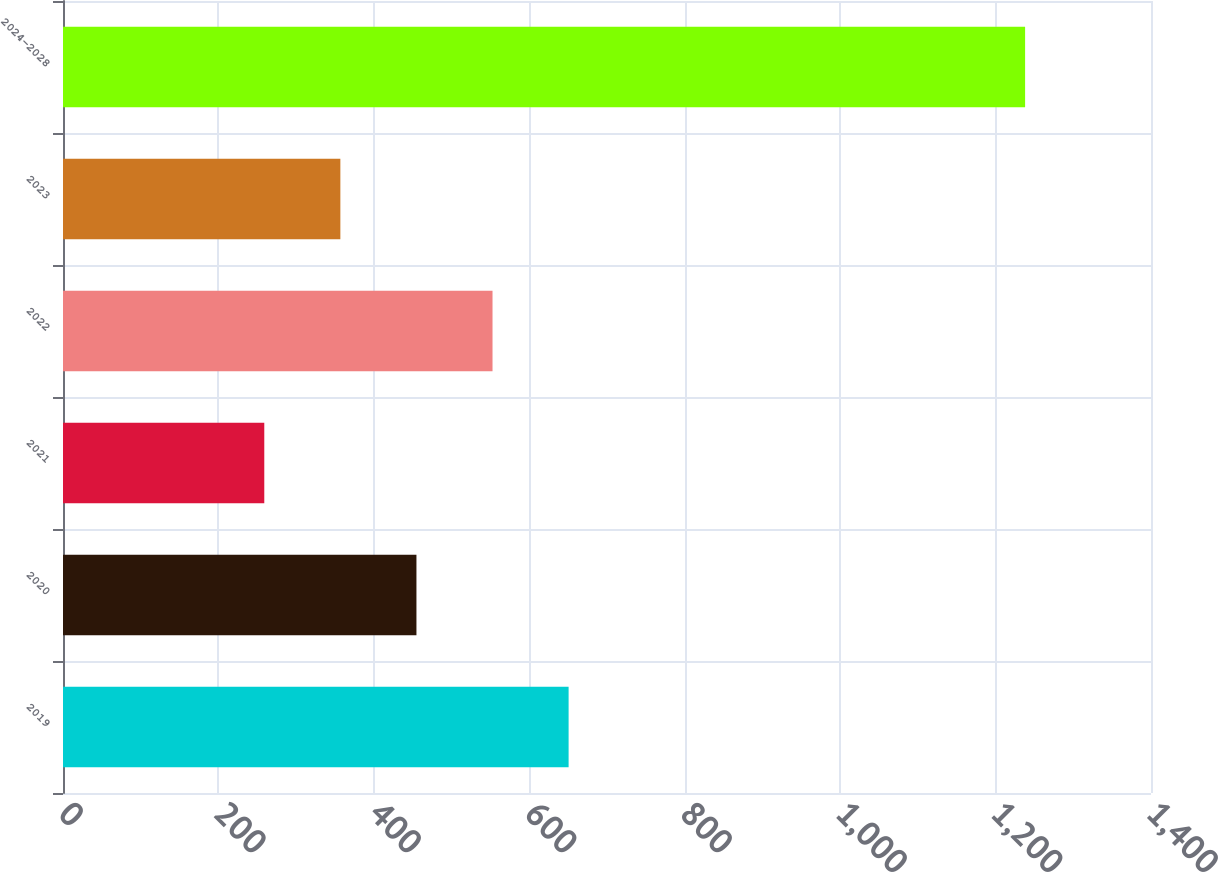<chart> <loc_0><loc_0><loc_500><loc_500><bar_chart><fcel>2019<fcel>2020<fcel>2021<fcel>2022<fcel>2023<fcel>2024-2028<nl><fcel>650.6<fcel>454.8<fcel>259<fcel>552.7<fcel>356.9<fcel>1238<nl></chart> 